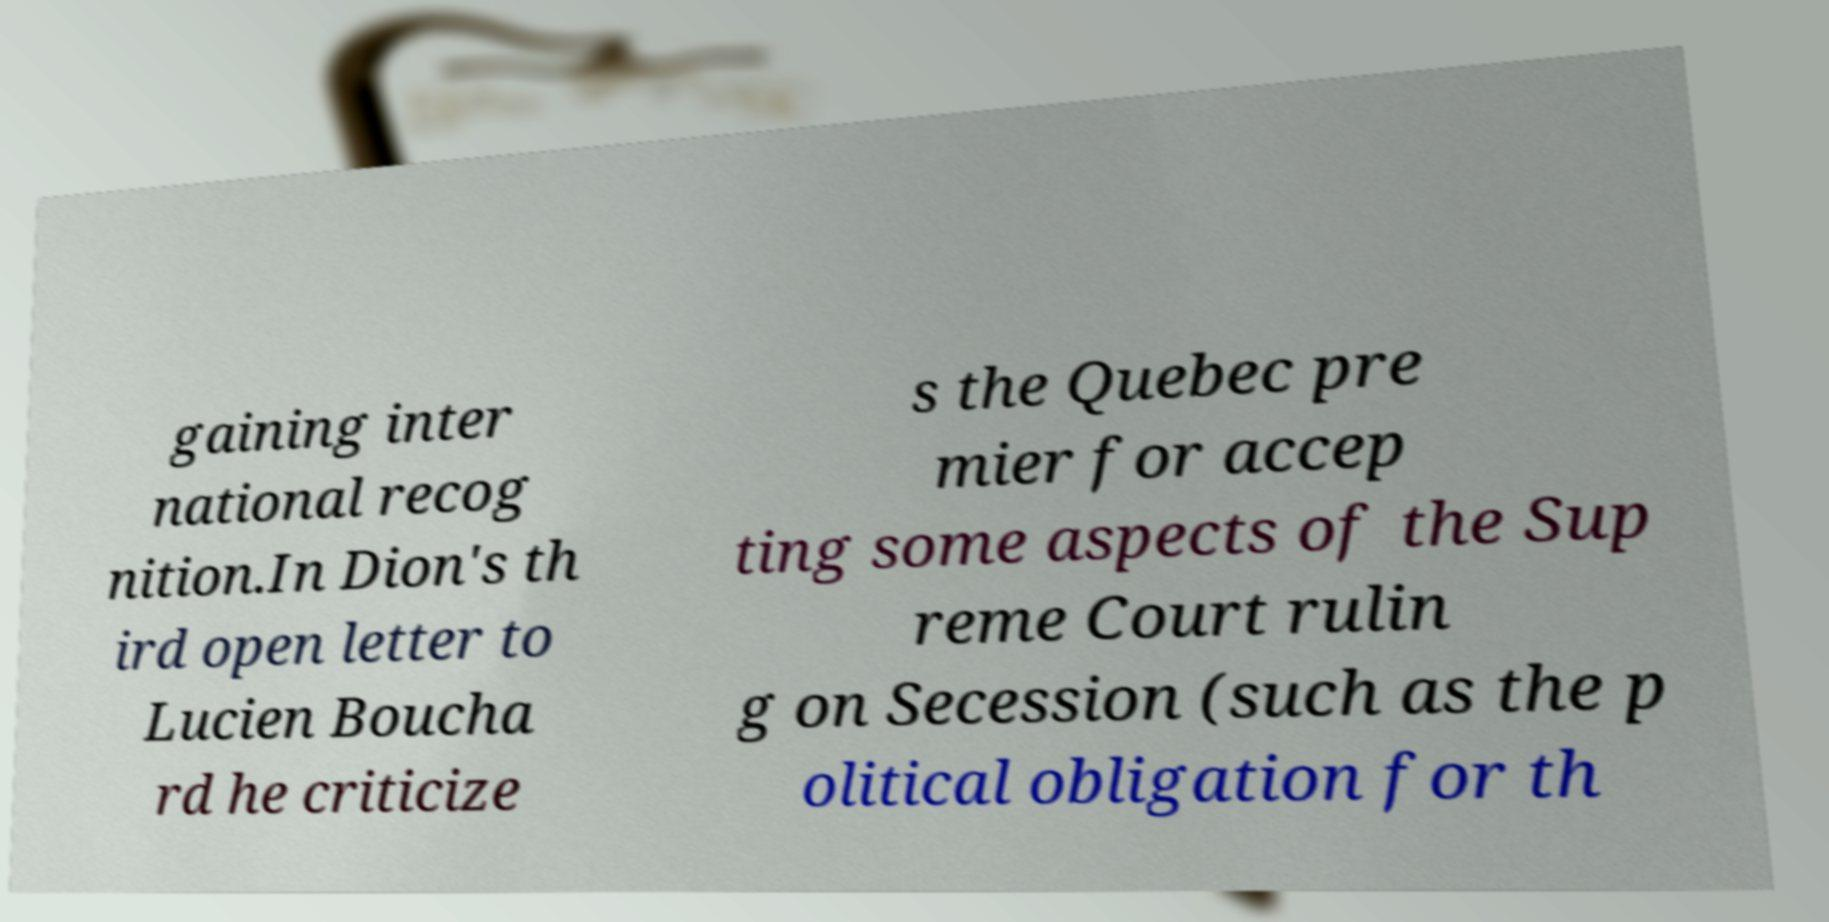Could you extract and type out the text from this image? gaining inter national recog nition.In Dion's th ird open letter to Lucien Boucha rd he criticize s the Quebec pre mier for accep ting some aspects of the Sup reme Court rulin g on Secession (such as the p olitical obligation for th 